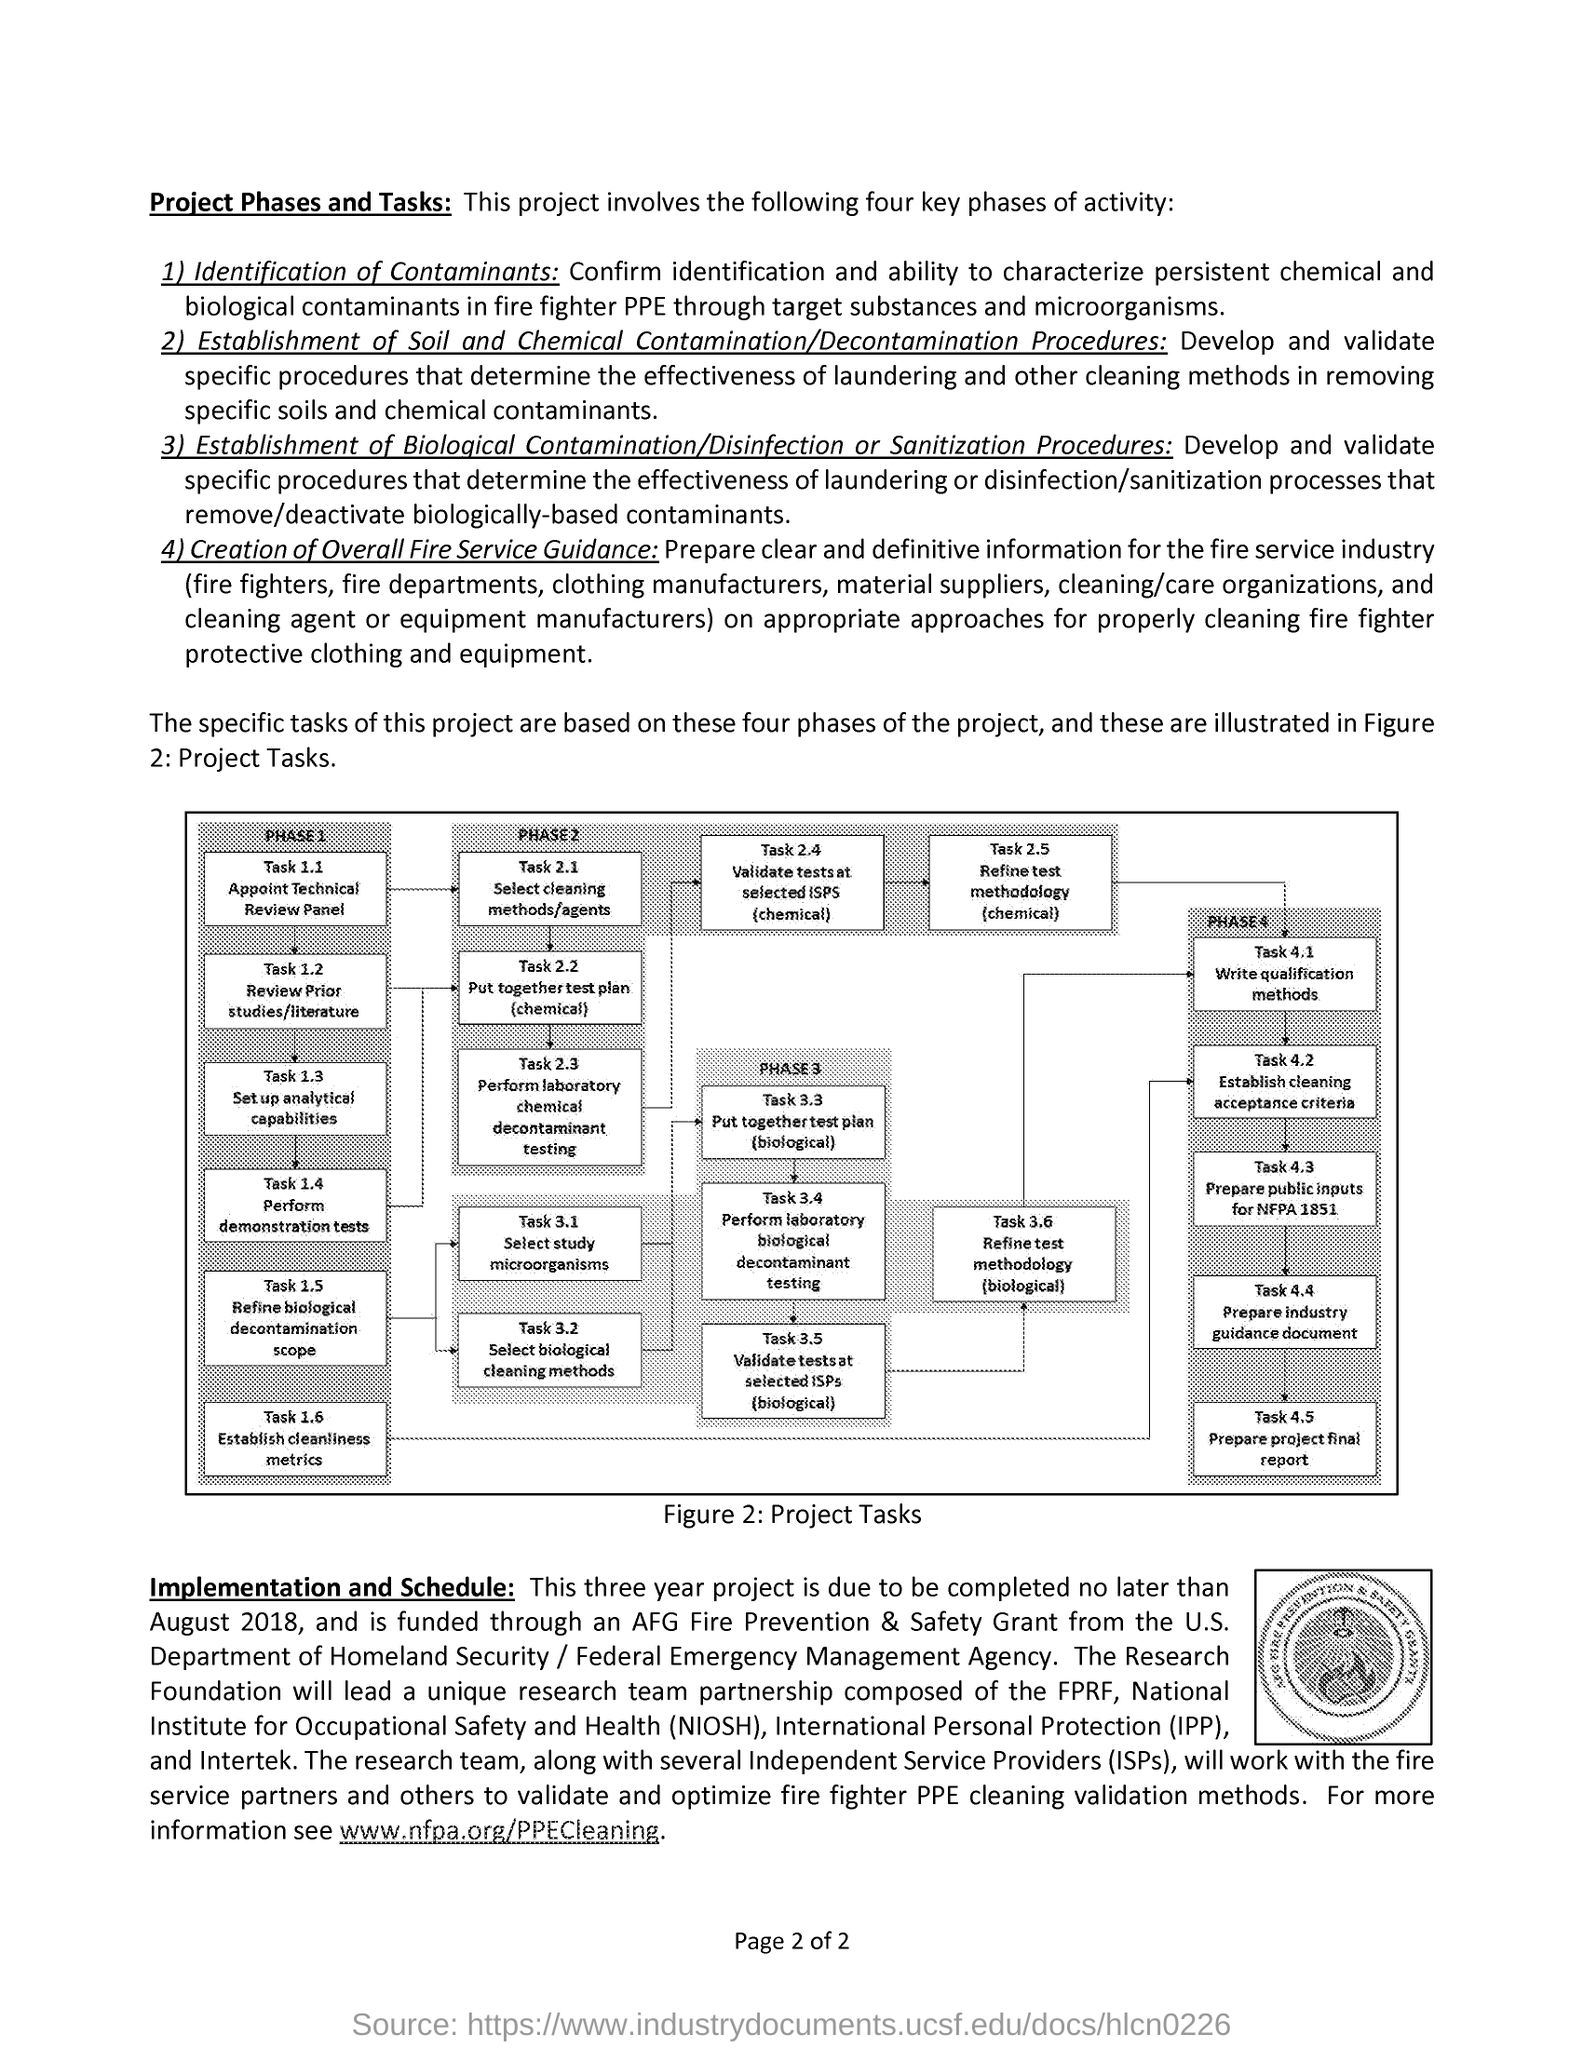Draw attention to some important aspects in this diagram. NIOSH stands for the National Institute for Occupational Safety and Health, which is a federal agency responsible for conducting research and making recommendations to prevent work-related injury and illness. Phase 1 task 1.2 involves reviewing prior studies and literature. IPP stands for International Personal Protection. The task 3.3 of phase 3 involves putting together a test plan for biological tests. 